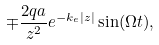<formula> <loc_0><loc_0><loc_500><loc_500>\mp \frac { 2 q a } { z ^ { 2 } } e ^ { - k _ { e } | z | } \sin ( \Omega t ) ,</formula> 